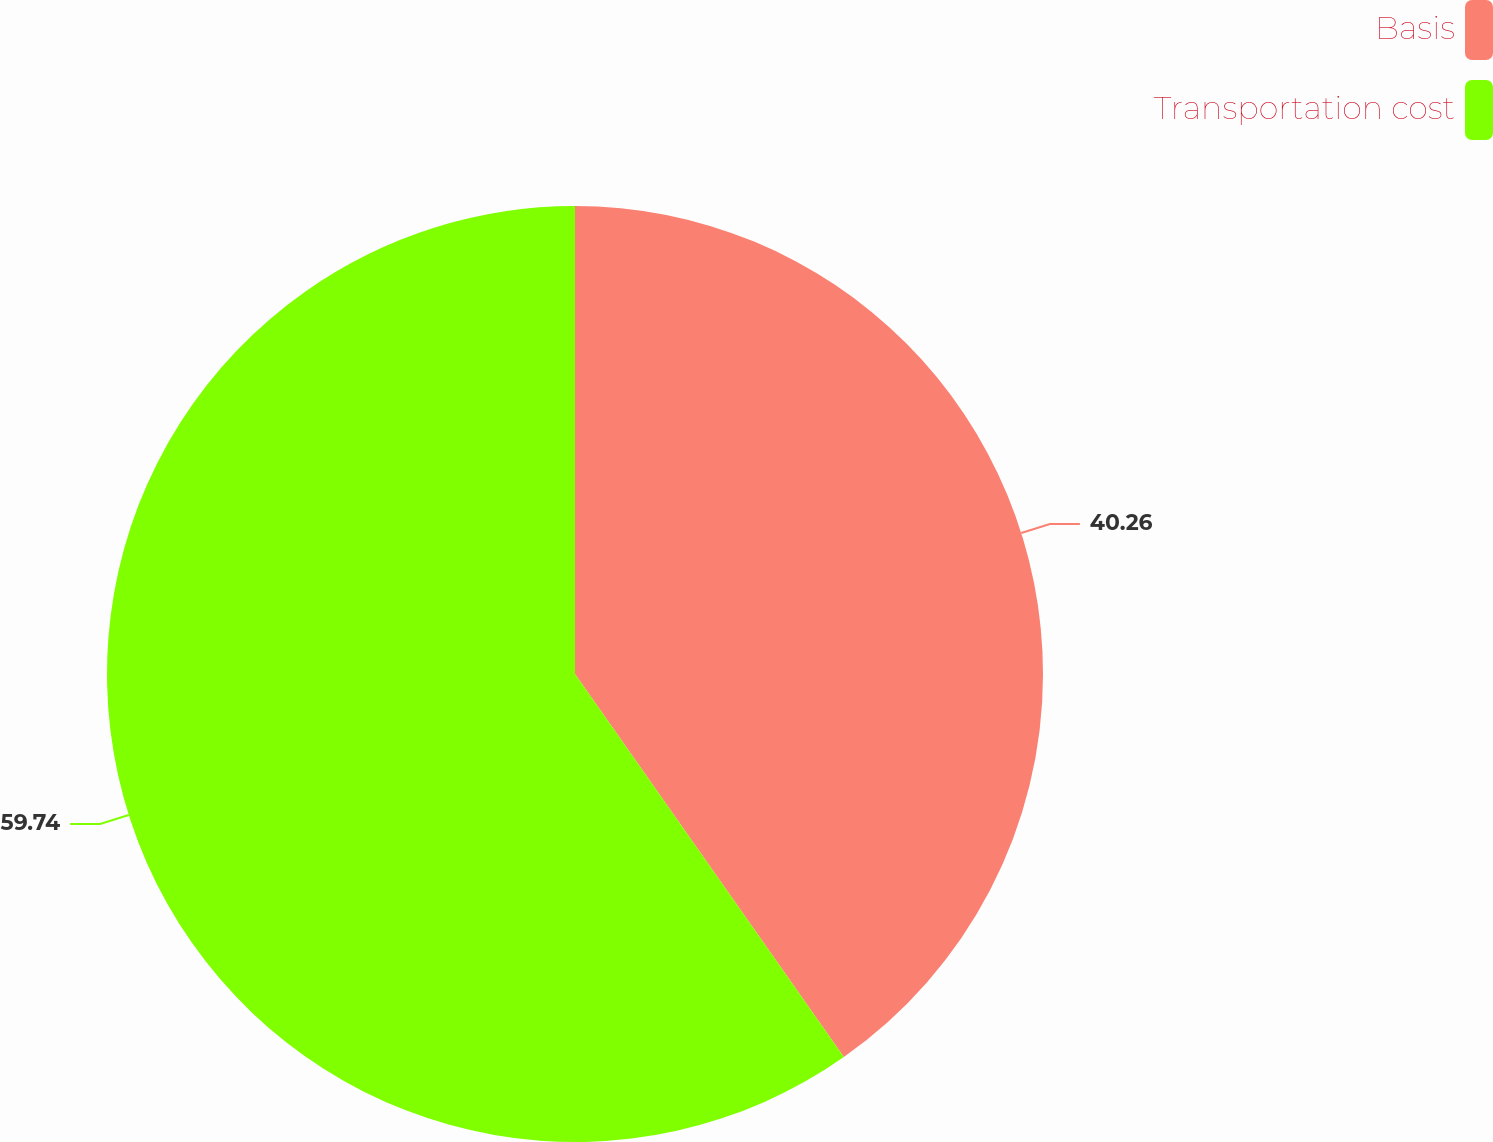Convert chart to OTSL. <chart><loc_0><loc_0><loc_500><loc_500><pie_chart><fcel>Basis<fcel>Transportation cost<nl><fcel>40.26%<fcel>59.74%<nl></chart> 